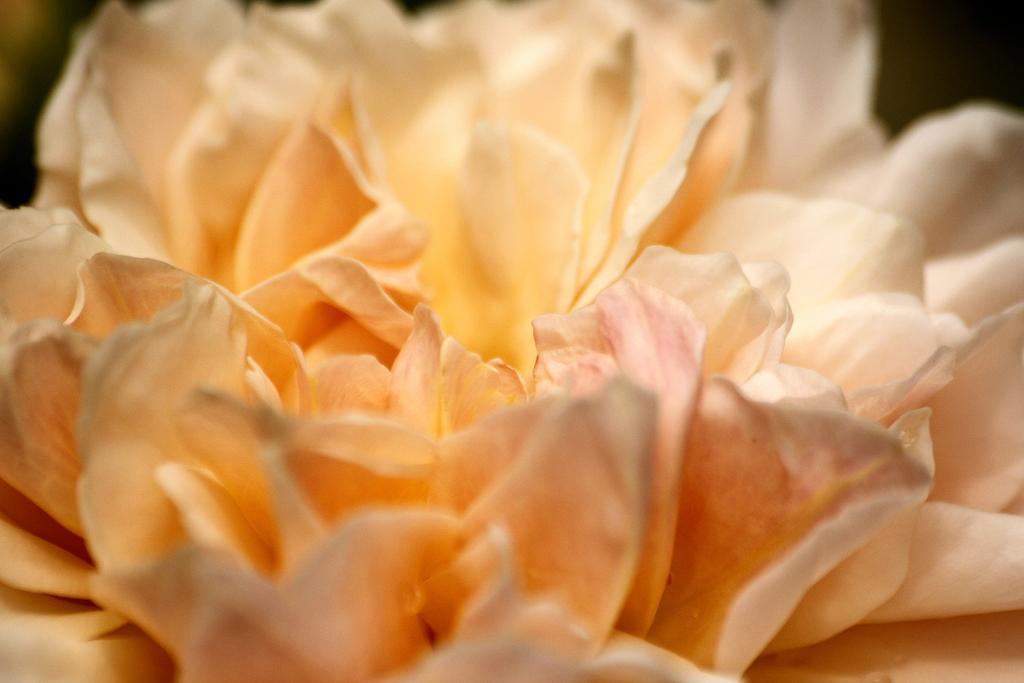Could you give a brief overview of what you see in this image? In the picture I can see the close view of a flower. The background of the image is blurred and dark. 